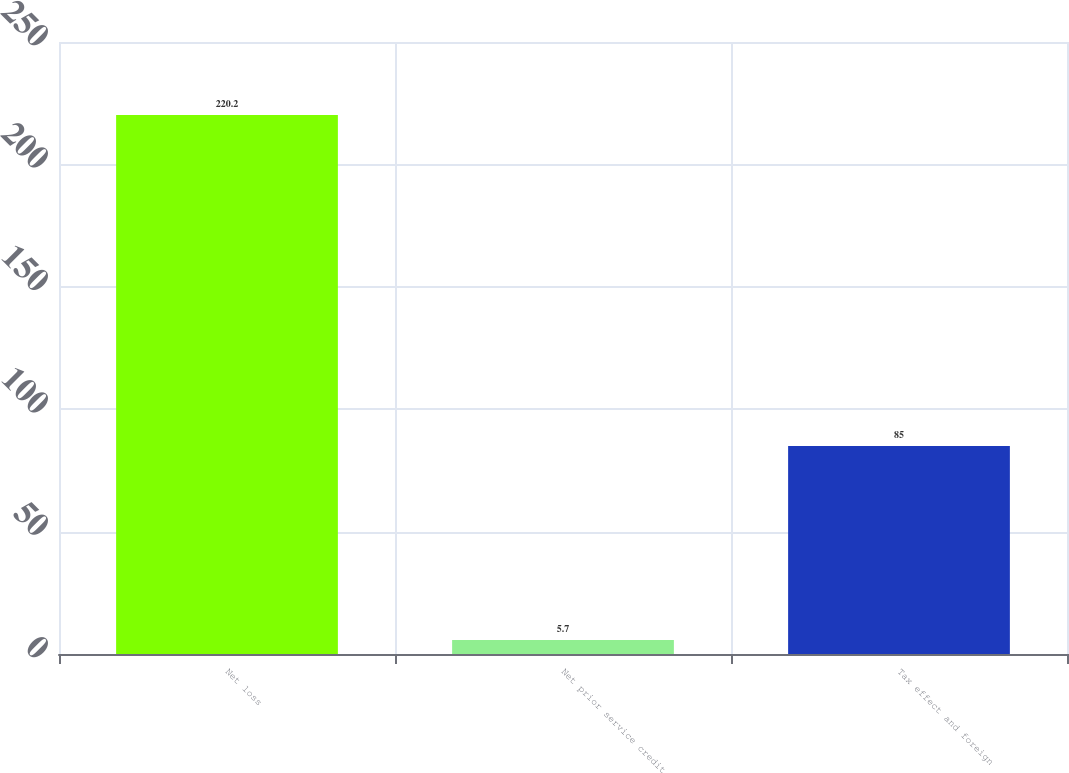<chart> <loc_0><loc_0><loc_500><loc_500><bar_chart><fcel>Net loss<fcel>Net prior service credit<fcel>Tax effect and foreign<nl><fcel>220.2<fcel>5.7<fcel>85<nl></chart> 